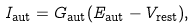Convert formula to latex. <formula><loc_0><loc_0><loc_500><loc_500>I _ { \text {aut} } = G _ { \text {aut} } ( E _ { \text {aut} } - V _ { \text {rest} } ) ,</formula> 